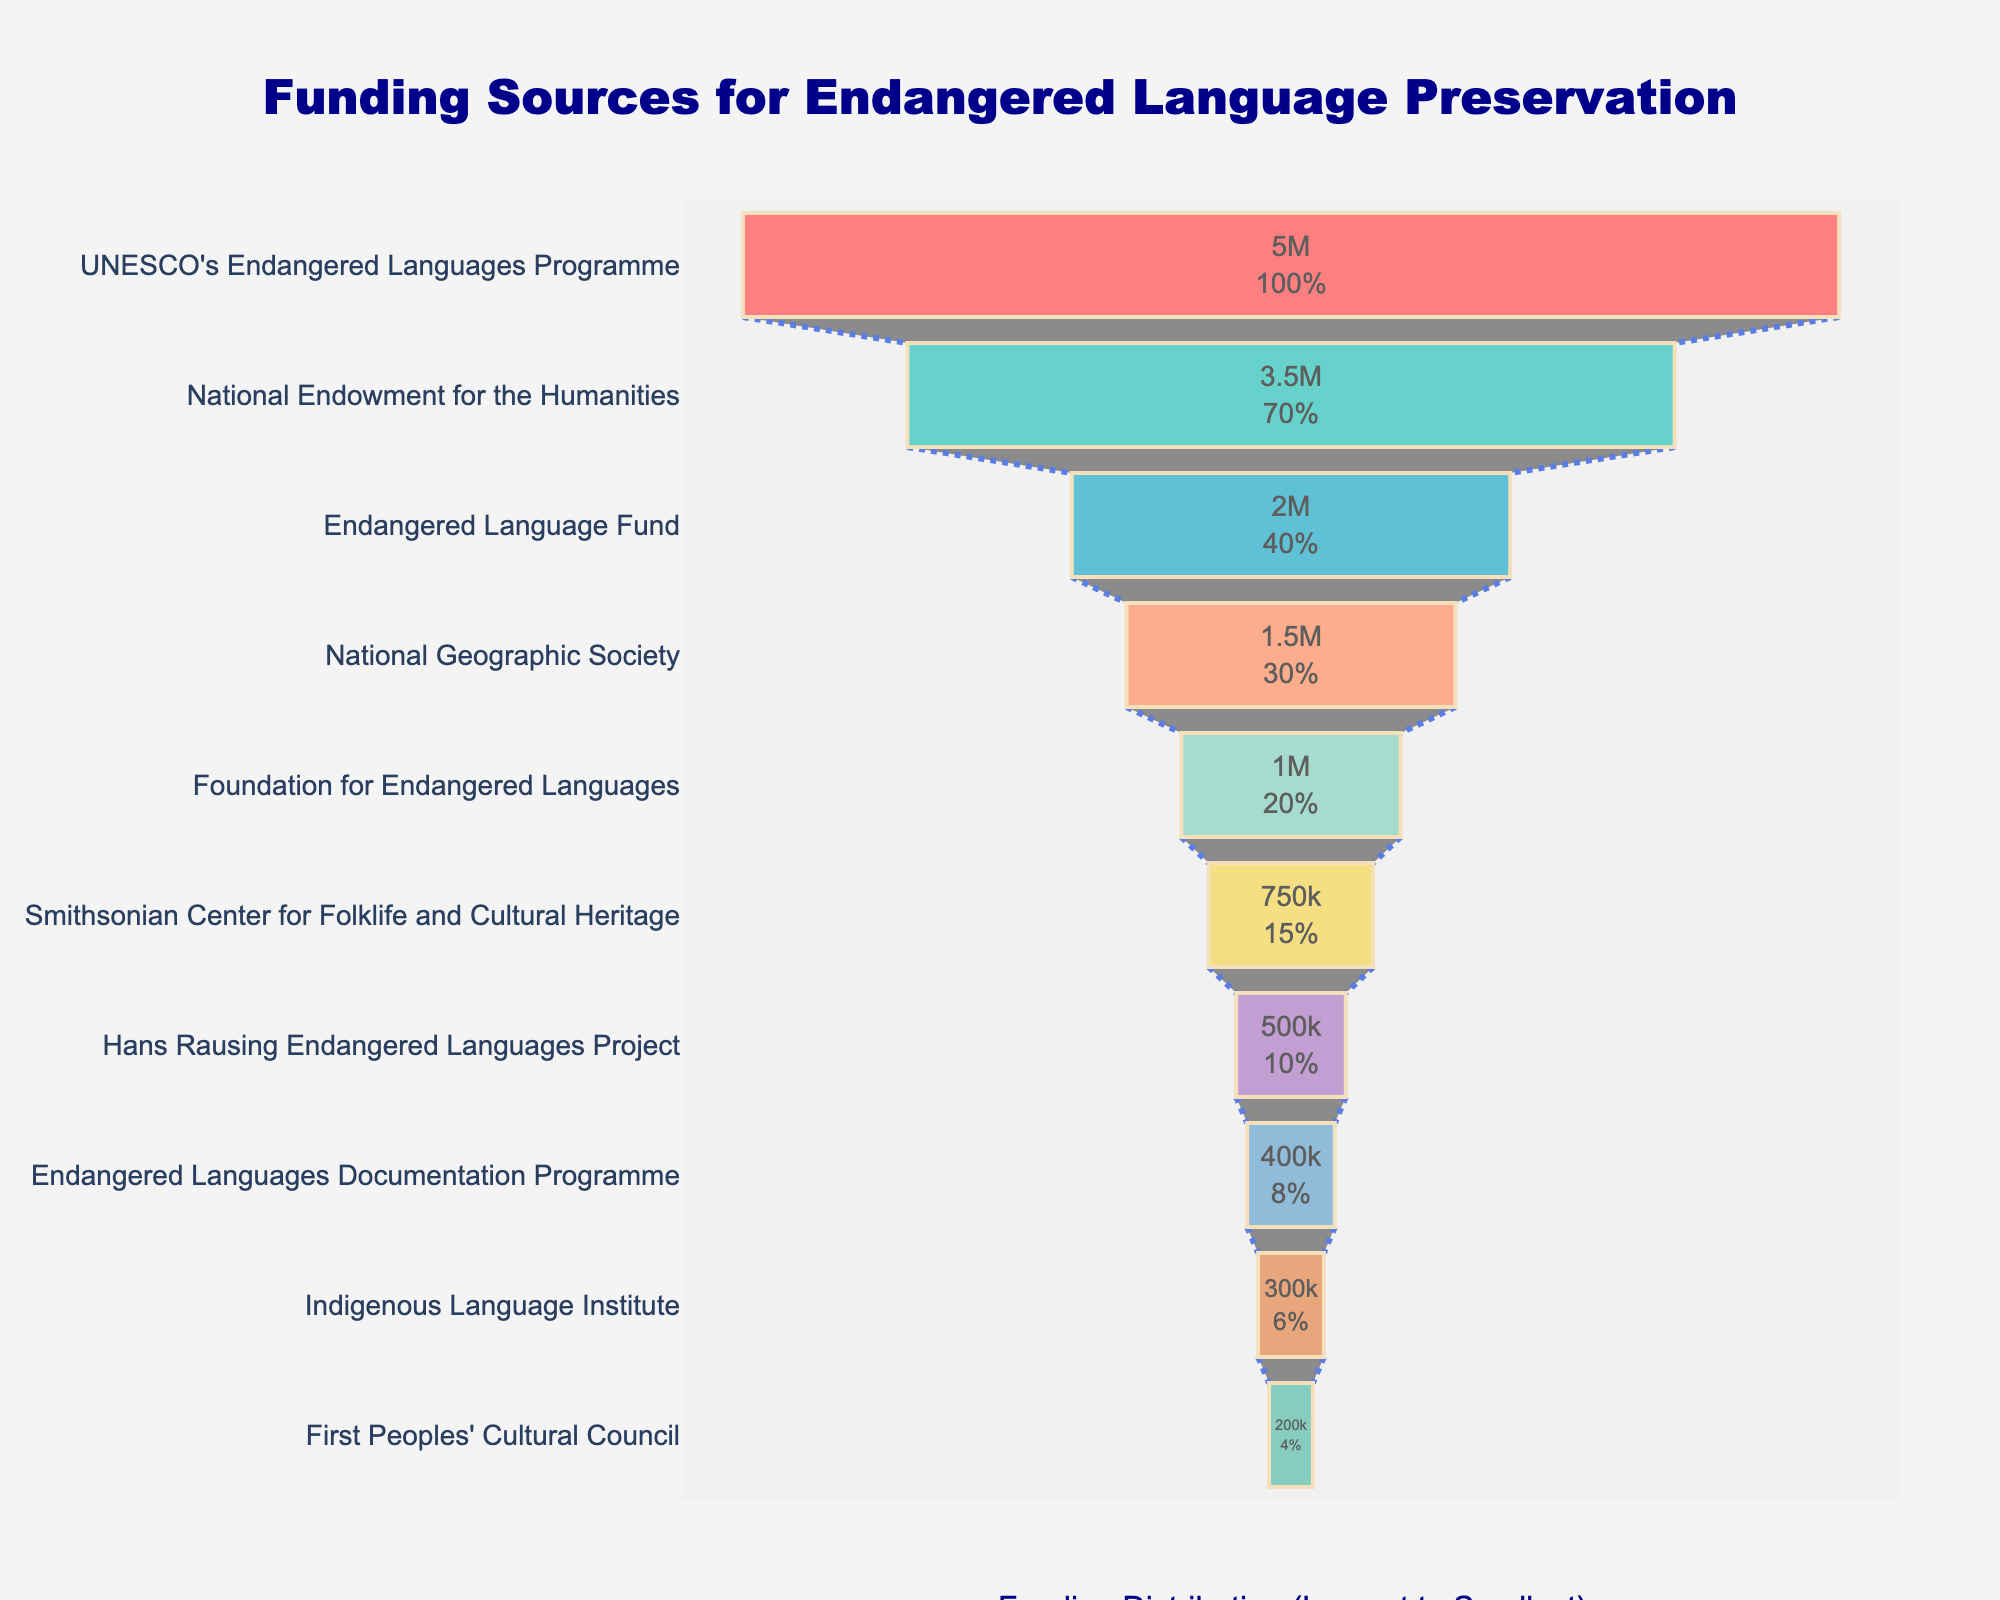What is the title of the figure? The title is written at the top of the chart and indicates what the figure is about.
Answer: Funding Sources for Endangered Language Preservation Which organization provides the most funding for endangered language preservation? The top of the funnel chart represents the largest contributor.
Answer: UNESCO's Endangered Languages Programme What is the amount contributed by the National Endowment for the Humanities? Locate the position of the National Endowment for the Humanities on the funnel chart and read the corresponding amount inside the bar.
Answer: 3,500,000 USD Which organization is the second smallest contributor? Look at the second bar from the bottom of the funnel chart.
Answer: Indigenous Language Institute How much funding do the top three contributors provide in total? Sum the amounts of the top three contributors: UNESCO's Endangered Languages Programme (5,000,000) + National Endowment for the Humanities (3,500,000) + Endangered Language Fund (2,000,000). 5,000,000 + 3,500,000 + 2,000,000 = 10,500,000 USD
Answer: 10,500,000 USD What percentage of the total funding does the Foundation for Endangered Languages contribute? Calculate the total funding by summing up all the amounts in the chart. Then, divide the amount contributed by the Foundation for Endangered Languages (1,000,000) by the total and multiply by 100 to get the percentage. Total = 5000000 + 3500000 + 2000000 + 1500000 + 1000000 + 750000 + 500000 + 400000 + 300000 + 200000 = 14,750,000. (1,000,000 / 14,750,000) * 100 ≈ 6.78%
Answer: 6.78% Is the amount contributed by the National Geographic Society greater than that of the Hans Rausing Endangered Languages Project? Compare the amounts of the National Geographic Society and Hans Rausing Endangered Languages Project in the funnel chart.
Answer: Yes What is the total funding for endangered language preservation contributed by organizations with less than 1,000,000 USD each? Add the amounts of organizations contributing less than 1,000,000 USD: Smithsonian Center for Folklife and Cultural Heritage (750,000) + Hans Rausing Endangered Languages Project (500,000) + Endangered Languages Documentation Programme (400,000) + Indigenous Language Institute (300,000) + First Peoples' Cultural Council (200,000). 750,000 + 500,000 + 400,000 + 300,000 + 200,000 = 2,150,000 USD
Answer: 2,150,000 USD Which organization is the third largest contributor? Look at the third bar from the top of the funnel chart.
Answer: Endangered Language Fund How does the funding amount of Smithsonian Center for Folklife and Cultural Heritage compare to that of the Foundation for Endangered Languages? Compare the amounts of both organizations in the funnel chart. The Smithsonian Center for Folklife and Cultural Heritage has 750,000, while the Foundation for Endangered Languages has 1,000,000.
Answer: The Foundation for Endangered Languages contributes more than the Smithsonian Center for Folklife and Cultural Heritage 